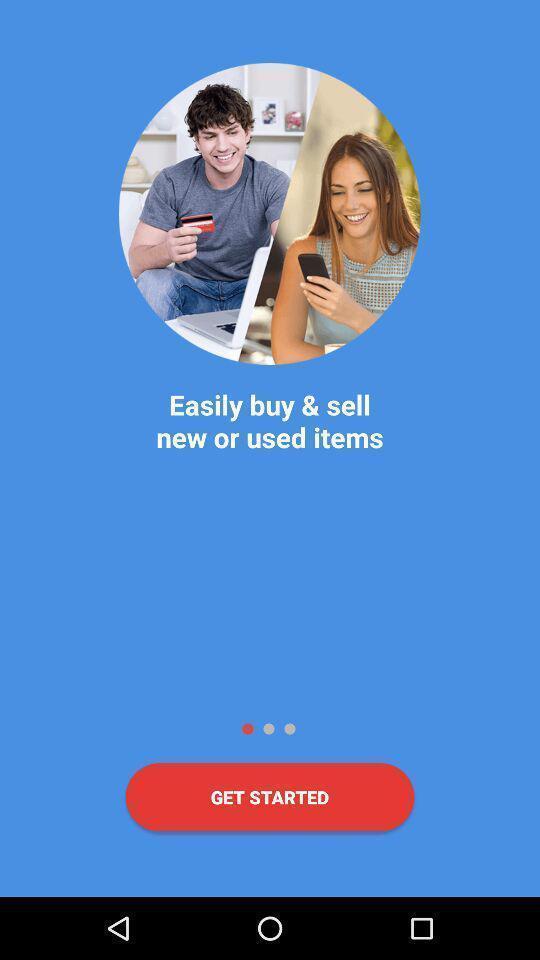Please provide a description for this image. Welcome page of the the app. 